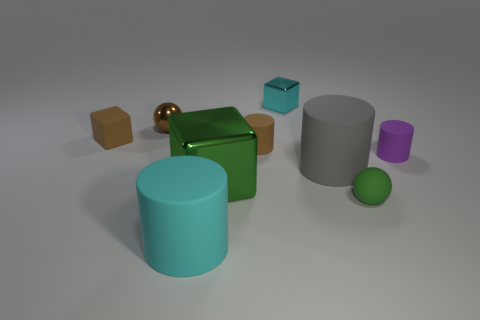Are there the same number of big rubber cylinders right of the green cube and large cyan matte cubes?
Keep it short and to the point. No. There is a rubber cylinder to the right of the large gray matte cylinder; are there any tiny balls right of it?
Your response must be concise. No. What number of other objects are the same color as the large metal thing?
Offer a very short reply. 1. The big shiny object is what color?
Give a very brief answer. Green. There is a metallic object that is both behind the purple object and right of the small metal sphere; how big is it?
Your response must be concise. Small. What number of things are either big cylinders that are on the left side of the large gray cylinder or tiny blue matte cylinders?
Your response must be concise. 1. There is a tiny green object that is the same material as the gray thing; what shape is it?
Provide a short and direct response. Sphere. What is the shape of the green metallic thing?
Your answer should be very brief. Cube. The block that is both behind the green block and in front of the brown shiny sphere is what color?
Provide a short and direct response. Brown. There is a purple thing that is the same size as the cyan cube; what shape is it?
Your response must be concise. Cylinder. 